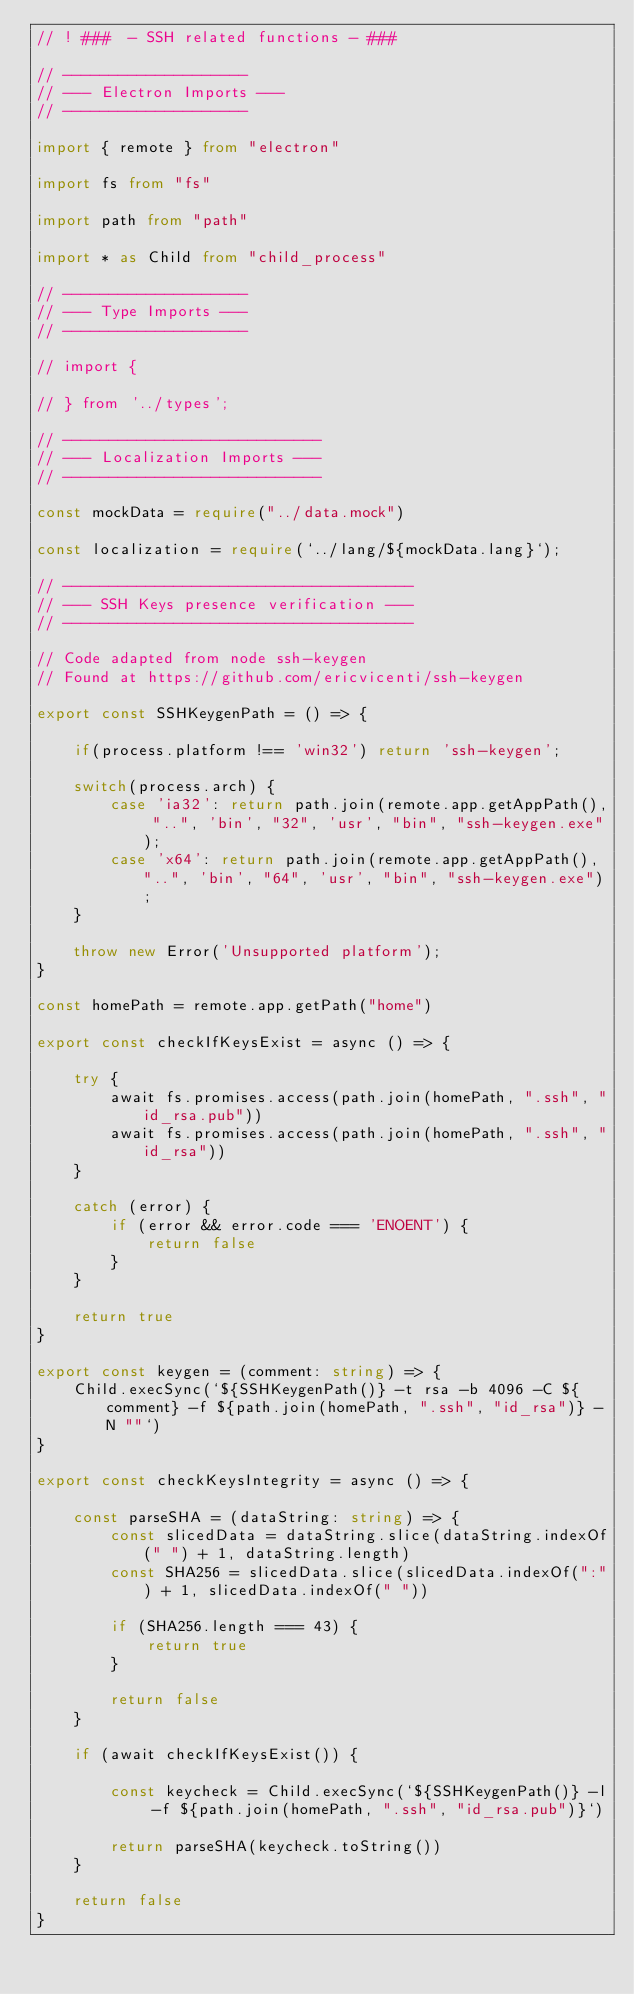Convert code to text. <code><loc_0><loc_0><loc_500><loc_500><_TypeScript_>// ! ###  - SSH related functions - ###

// --------------------
// --- Electron Imports ---
// --------------------

import { remote } from "electron"

import fs from "fs"

import path from "path"

import * as Child from "child_process"

// --------------------
// --- Type Imports ---
// --------------------

// import {
    
// } from '../types';

// ----------------------------
// --- Localization Imports ---
// ----------------------------

const mockData = require("../data.mock")

const localization = require(`../lang/${mockData.lang}`);

// --------------------------------------
// --- SSH Keys presence verification ---
// --------------------------------------

// Code adapted from node ssh-keygen
// Found at https://github.com/ericvicenti/ssh-keygen

export const SSHKeygenPath = () => {

    if(process.platform !== 'win32') return 'ssh-keygen';

    switch(process.arch) {
        case 'ia32': return path.join(remote.app.getAppPath(), "..", 'bin', "32", 'usr', "bin", "ssh-keygen.exe");
        case 'x64': return path.join(remote.app.getAppPath(), "..", 'bin', "64", 'usr', "bin", "ssh-keygen.exe");
    }

    throw new Error('Unsupported platform');
}

const homePath = remote.app.getPath("home")

export const checkIfKeysExist = async () => {

    try {
        await fs.promises.access(path.join(homePath, ".ssh", "id_rsa.pub"))
        await fs.promises.access(path.join(homePath, ".ssh", "id_rsa"))
    }

    catch (error) {
        if (error && error.code === 'ENOENT') {
            return false
        } 
    }

    return true
}

export const keygen = (comment: string) => { 
    Child.execSync(`${SSHKeygenPath()} -t rsa -b 4096 -C ${comment} -f ${path.join(homePath, ".ssh", "id_rsa")} -N ""`)
}

export const checkKeysIntegrity = async () => {

    const parseSHA = (dataString: string) => {
        const slicedData = dataString.slice(dataString.indexOf(" ") + 1, dataString.length)
        const SHA256 = slicedData.slice(slicedData.indexOf(":") + 1, slicedData.indexOf(" "))

        if (SHA256.length === 43) {
            return true
        }

        return false
    }

    if (await checkIfKeysExist()) {
    
        const keycheck = Child.execSync(`${SSHKeygenPath()} -l -f ${path.join(homePath, ".ssh", "id_rsa.pub")}`)

        return parseSHA(keycheck.toString())
    }
    
    return false
}   </code> 